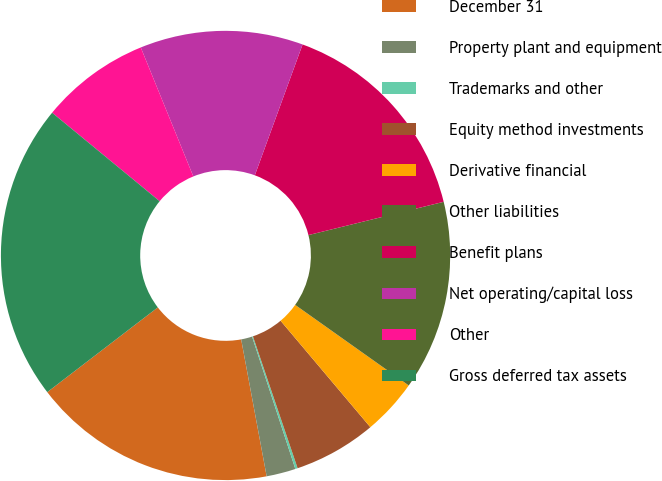<chart> <loc_0><loc_0><loc_500><loc_500><pie_chart><fcel>December 31<fcel>Property plant and equipment<fcel>Trademarks and other<fcel>Equity method investments<fcel>Derivative financial<fcel>Other liabilities<fcel>Benefit plans<fcel>Net operating/capital loss<fcel>Other<fcel>Gross deferred tax assets<nl><fcel>17.52%<fcel>2.1%<fcel>0.17%<fcel>5.95%<fcel>4.03%<fcel>13.66%<fcel>15.59%<fcel>11.73%<fcel>7.88%<fcel>21.37%<nl></chart> 